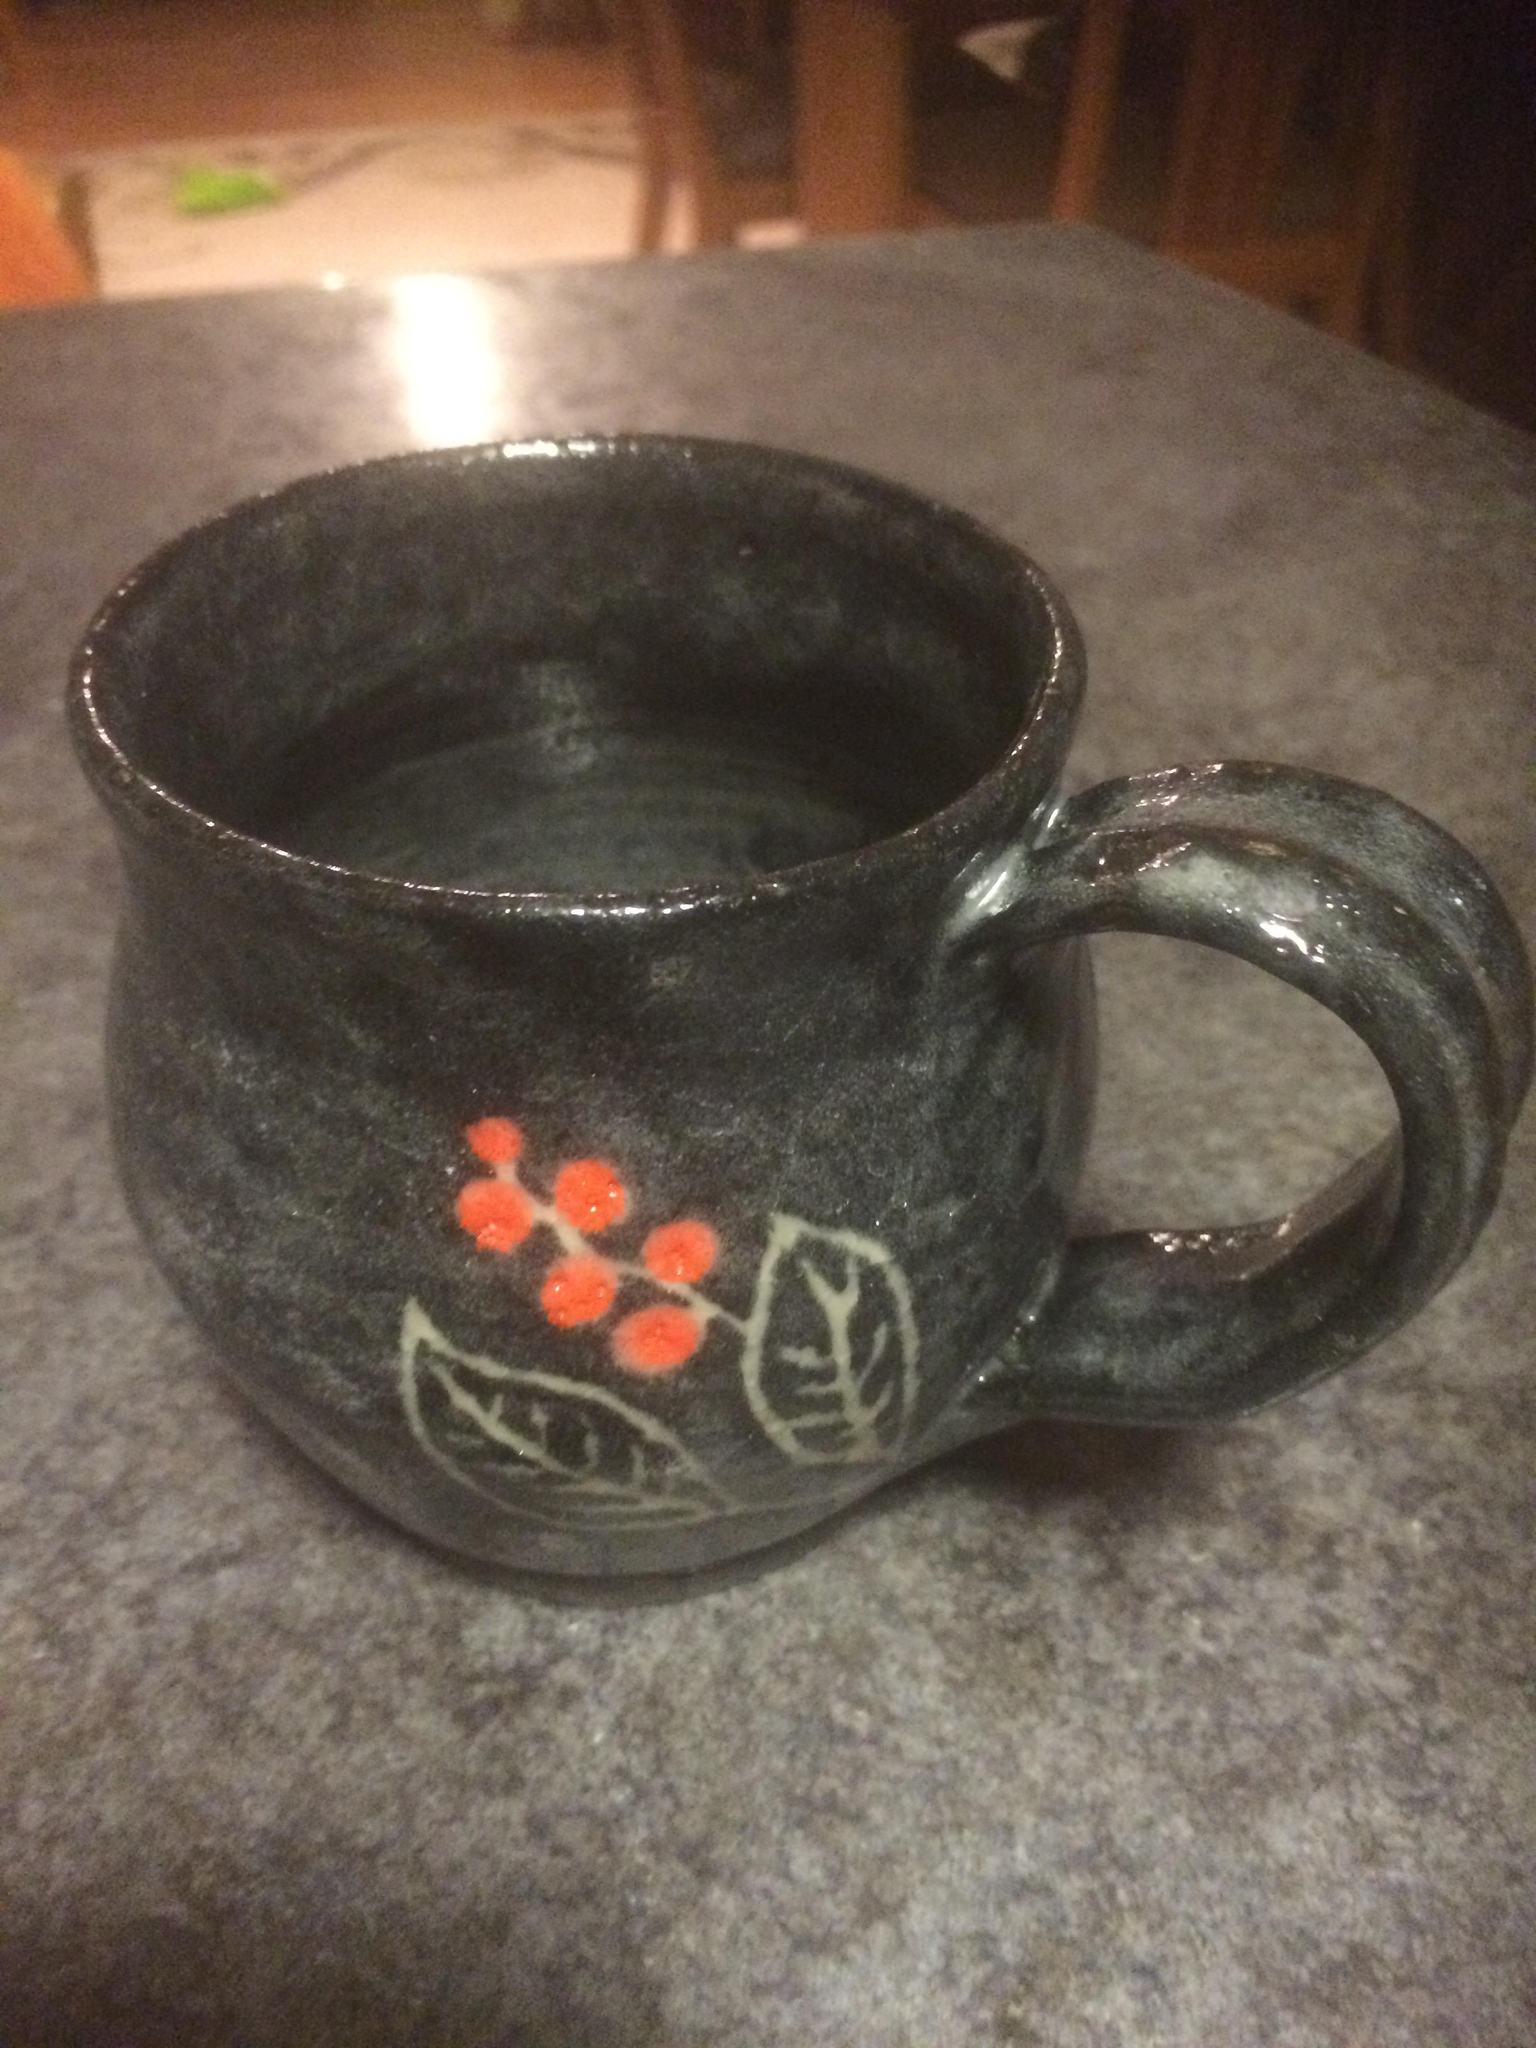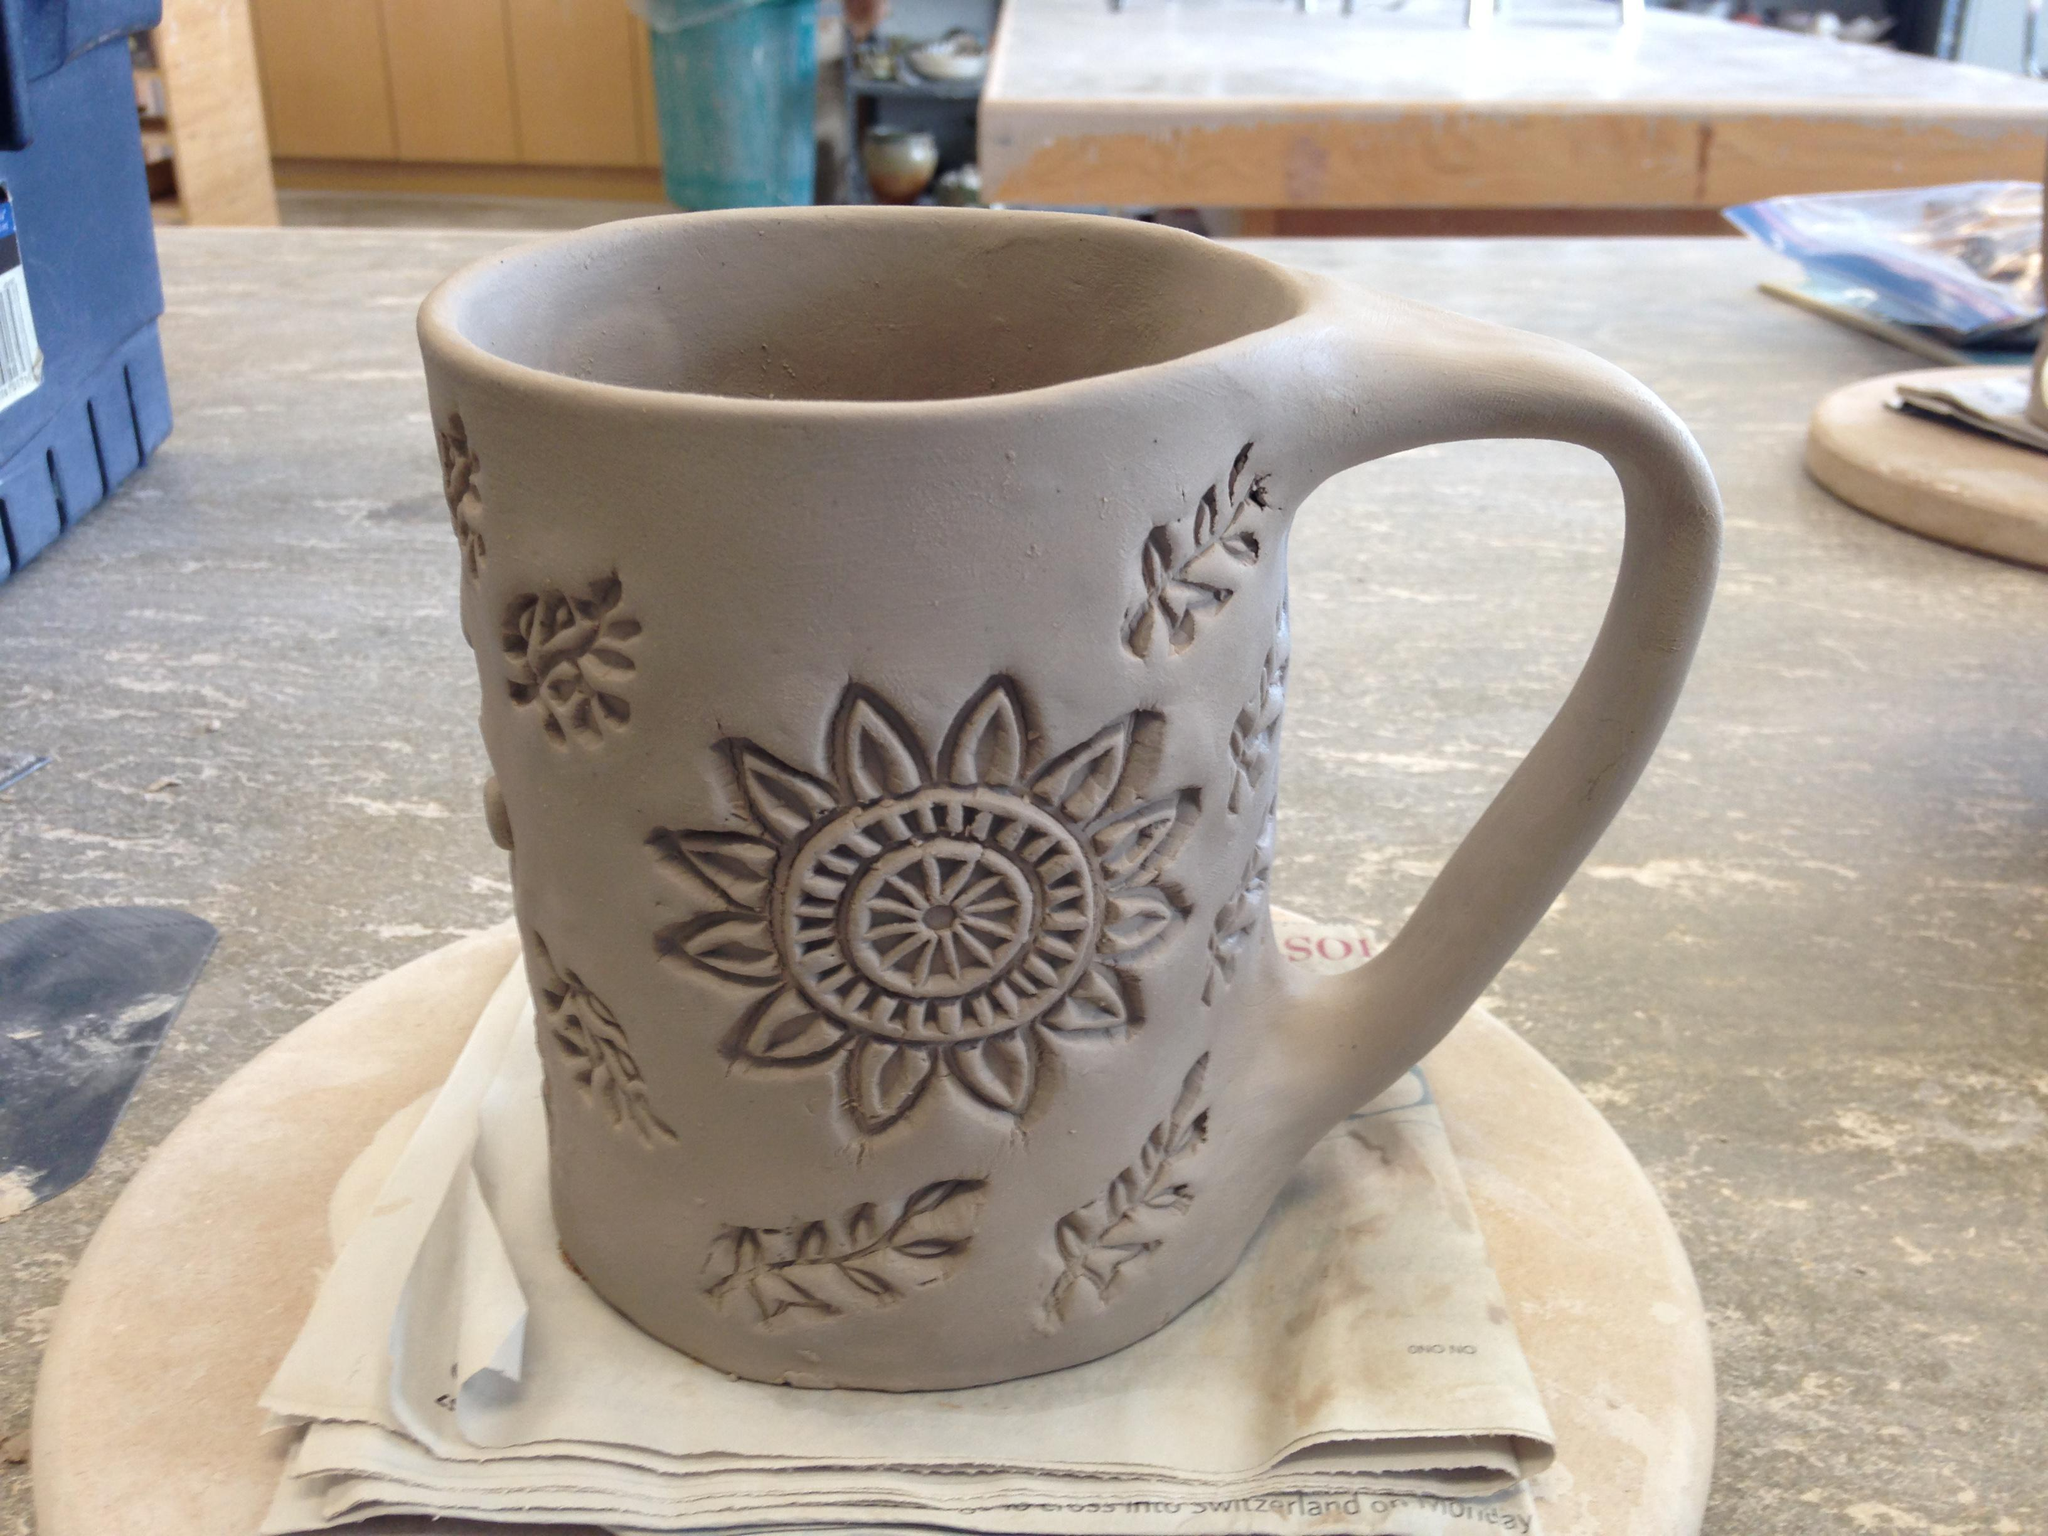The first image is the image on the left, the second image is the image on the right. For the images shown, is this caption "There are more than 2 cups." true? Answer yes or no. No. The first image is the image on the left, the second image is the image on the right. Assess this claim about the two images: "The left and right image contains the same number  of cups.". Correct or not? Answer yes or no. Yes. 